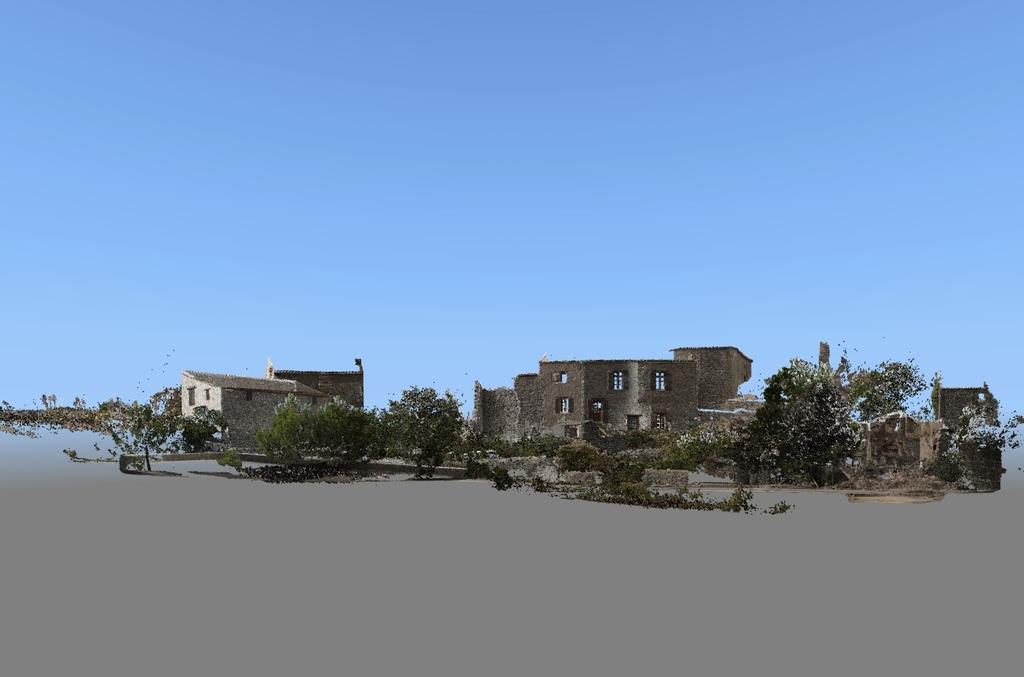Please provide a concise description of this image. This is an edited image. In this image we can see trees and buildings with windows. At the top of the image there is sky. 